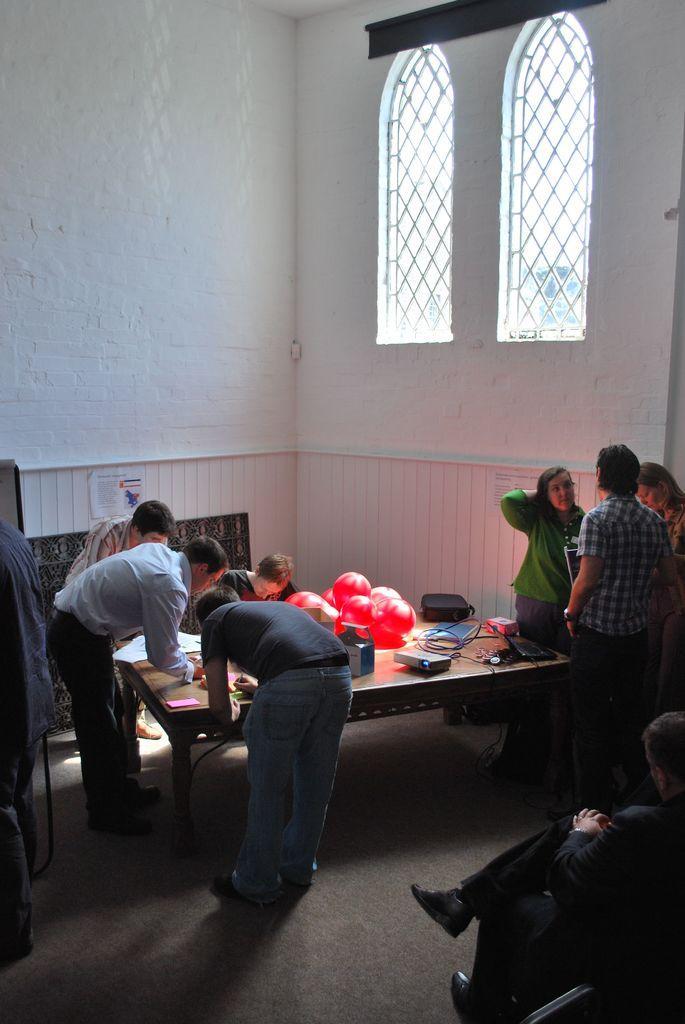In one or two sentences, can you explain what this image depicts? As we can see in the image, there are group of people standing around table. On table there is a projector and balloons and the man on the right is sitting on chair and the wall is in white color. 